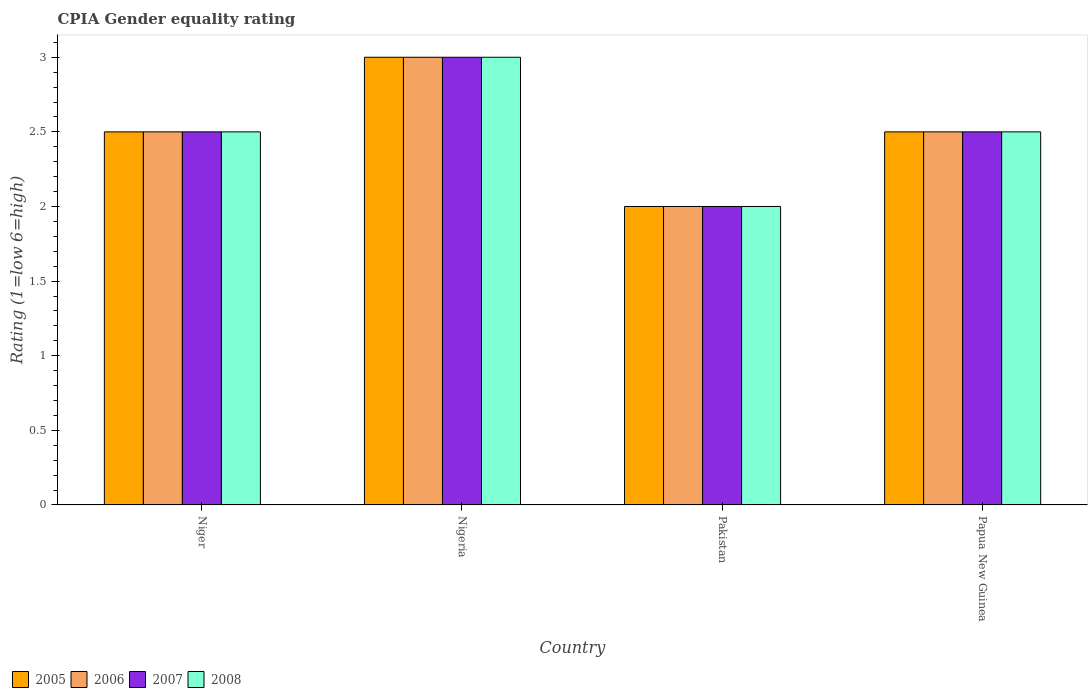How many different coloured bars are there?
Provide a succinct answer. 4. How many groups of bars are there?
Your answer should be compact. 4. Are the number of bars per tick equal to the number of legend labels?
Ensure brevity in your answer.  Yes. What is the label of the 4th group of bars from the left?
Provide a short and direct response. Papua New Guinea. In how many cases, is the number of bars for a given country not equal to the number of legend labels?
Your answer should be compact. 0. Across all countries, what is the minimum CPIA rating in 2008?
Give a very brief answer. 2. In which country was the CPIA rating in 2007 maximum?
Your answer should be very brief. Nigeria. In which country was the CPIA rating in 2005 minimum?
Ensure brevity in your answer.  Pakistan. What is the difference between the CPIA rating of/in 2008 and CPIA rating of/in 2005 in Nigeria?
Give a very brief answer. 0. In how many countries, is the CPIA rating in 2005 greater than 2.1?
Give a very brief answer. 3. What is the ratio of the CPIA rating in 2007 in Pakistan to that in Papua New Guinea?
Your answer should be very brief. 0.8. What is the difference between the highest and the second highest CPIA rating in 2008?
Provide a short and direct response. -0.5. Is the sum of the CPIA rating in 2008 in Niger and Pakistan greater than the maximum CPIA rating in 2006 across all countries?
Your response must be concise. Yes. Are all the bars in the graph horizontal?
Your response must be concise. No. How many countries are there in the graph?
Your response must be concise. 4. What is the difference between two consecutive major ticks on the Y-axis?
Your answer should be very brief. 0.5. Does the graph contain any zero values?
Your answer should be compact. No. Does the graph contain grids?
Provide a short and direct response. No. Where does the legend appear in the graph?
Provide a short and direct response. Bottom left. How many legend labels are there?
Offer a terse response. 4. What is the title of the graph?
Your answer should be very brief. CPIA Gender equality rating. Does "1961" appear as one of the legend labels in the graph?
Provide a succinct answer. No. What is the label or title of the Y-axis?
Your answer should be compact. Rating (1=low 6=high). What is the Rating (1=low 6=high) of 2006 in Niger?
Ensure brevity in your answer.  2.5. What is the Rating (1=low 6=high) in 2007 in Niger?
Provide a succinct answer. 2.5. What is the Rating (1=low 6=high) in 2007 in Nigeria?
Make the answer very short. 3. What is the Rating (1=low 6=high) in 2008 in Nigeria?
Provide a short and direct response. 3. What is the Rating (1=low 6=high) of 2006 in Pakistan?
Your answer should be very brief. 2. What is the Rating (1=low 6=high) in 2006 in Papua New Guinea?
Your answer should be very brief. 2.5. Across all countries, what is the maximum Rating (1=low 6=high) in 2005?
Your answer should be very brief. 3. Across all countries, what is the maximum Rating (1=low 6=high) in 2008?
Your answer should be compact. 3. Across all countries, what is the minimum Rating (1=low 6=high) of 2007?
Make the answer very short. 2. What is the total Rating (1=low 6=high) of 2006 in the graph?
Your answer should be very brief. 10. What is the total Rating (1=low 6=high) of 2007 in the graph?
Offer a very short reply. 10. What is the total Rating (1=low 6=high) of 2008 in the graph?
Your answer should be compact. 10. What is the difference between the Rating (1=low 6=high) of 2005 in Niger and that in Nigeria?
Offer a terse response. -0.5. What is the difference between the Rating (1=low 6=high) of 2006 in Niger and that in Nigeria?
Give a very brief answer. -0.5. What is the difference between the Rating (1=low 6=high) in 2007 in Niger and that in Nigeria?
Your response must be concise. -0.5. What is the difference between the Rating (1=low 6=high) of 2006 in Niger and that in Pakistan?
Keep it short and to the point. 0.5. What is the difference between the Rating (1=low 6=high) in 2008 in Niger and that in Pakistan?
Give a very brief answer. 0.5. What is the difference between the Rating (1=low 6=high) in 2005 in Niger and that in Papua New Guinea?
Your answer should be compact. 0. What is the difference between the Rating (1=low 6=high) of 2006 in Niger and that in Papua New Guinea?
Offer a terse response. 0. What is the difference between the Rating (1=low 6=high) of 2008 in Niger and that in Papua New Guinea?
Make the answer very short. 0. What is the difference between the Rating (1=low 6=high) of 2006 in Nigeria and that in Pakistan?
Provide a short and direct response. 1. What is the difference between the Rating (1=low 6=high) in 2008 in Nigeria and that in Pakistan?
Offer a terse response. 1. What is the difference between the Rating (1=low 6=high) in 2005 in Nigeria and that in Papua New Guinea?
Provide a succinct answer. 0.5. What is the difference between the Rating (1=low 6=high) of 2006 in Nigeria and that in Papua New Guinea?
Provide a short and direct response. 0.5. What is the difference between the Rating (1=low 6=high) in 2007 in Nigeria and that in Papua New Guinea?
Your answer should be compact. 0.5. What is the difference between the Rating (1=low 6=high) in 2008 in Nigeria and that in Papua New Guinea?
Your answer should be compact. 0.5. What is the difference between the Rating (1=low 6=high) in 2006 in Pakistan and that in Papua New Guinea?
Make the answer very short. -0.5. What is the difference between the Rating (1=low 6=high) of 2008 in Pakistan and that in Papua New Guinea?
Provide a succinct answer. -0.5. What is the difference between the Rating (1=low 6=high) in 2005 in Niger and the Rating (1=low 6=high) in 2006 in Nigeria?
Offer a terse response. -0.5. What is the difference between the Rating (1=low 6=high) of 2005 in Niger and the Rating (1=low 6=high) of 2007 in Pakistan?
Make the answer very short. 0.5. What is the difference between the Rating (1=low 6=high) in 2005 in Niger and the Rating (1=low 6=high) in 2008 in Pakistan?
Your response must be concise. 0.5. What is the difference between the Rating (1=low 6=high) of 2007 in Niger and the Rating (1=low 6=high) of 2008 in Pakistan?
Give a very brief answer. 0.5. What is the difference between the Rating (1=low 6=high) of 2005 in Niger and the Rating (1=low 6=high) of 2007 in Papua New Guinea?
Ensure brevity in your answer.  0. What is the difference between the Rating (1=low 6=high) of 2005 in Niger and the Rating (1=low 6=high) of 2008 in Papua New Guinea?
Your answer should be compact. 0. What is the difference between the Rating (1=low 6=high) in 2006 in Niger and the Rating (1=low 6=high) in 2007 in Papua New Guinea?
Keep it short and to the point. 0. What is the difference between the Rating (1=low 6=high) in 2006 in Niger and the Rating (1=low 6=high) in 2008 in Papua New Guinea?
Give a very brief answer. 0. What is the difference between the Rating (1=low 6=high) in 2005 in Nigeria and the Rating (1=low 6=high) in 2007 in Pakistan?
Offer a terse response. 1. What is the difference between the Rating (1=low 6=high) in 2006 in Nigeria and the Rating (1=low 6=high) in 2008 in Pakistan?
Ensure brevity in your answer.  1. What is the difference between the Rating (1=low 6=high) of 2005 in Nigeria and the Rating (1=low 6=high) of 2008 in Papua New Guinea?
Your answer should be compact. 0.5. What is the difference between the Rating (1=low 6=high) in 2007 in Nigeria and the Rating (1=low 6=high) in 2008 in Papua New Guinea?
Offer a terse response. 0.5. What is the difference between the Rating (1=low 6=high) of 2006 in Pakistan and the Rating (1=low 6=high) of 2007 in Papua New Guinea?
Your answer should be very brief. -0.5. What is the difference between the Rating (1=low 6=high) of 2005 and Rating (1=low 6=high) of 2006 in Niger?
Your response must be concise. 0. What is the difference between the Rating (1=low 6=high) in 2005 and Rating (1=low 6=high) in 2008 in Niger?
Your answer should be very brief. 0. What is the difference between the Rating (1=low 6=high) of 2006 and Rating (1=low 6=high) of 2008 in Niger?
Provide a short and direct response. 0. What is the difference between the Rating (1=low 6=high) of 2005 and Rating (1=low 6=high) of 2006 in Nigeria?
Your answer should be very brief. 0. What is the difference between the Rating (1=low 6=high) in 2005 and Rating (1=low 6=high) in 2007 in Nigeria?
Your answer should be compact. 0. What is the difference between the Rating (1=low 6=high) in 2007 and Rating (1=low 6=high) in 2008 in Nigeria?
Your answer should be compact. 0. What is the difference between the Rating (1=low 6=high) of 2005 and Rating (1=low 6=high) of 2007 in Pakistan?
Your response must be concise. 0. What is the difference between the Rating (1=low 6=high) of 2006 and Rating (1=low 6=high) of 2007 in Pakistan?
Your answer should be very brief. 0. What is the difference between the Rating (1=low 6=high) in 2007 and Rating (1=low 6=high) in 2008 in Pakistan?
Your answer should be compact. 0. What is the difference between the Rating (1=low 6=high) in 2005 and Rating (1=low 6=high) in 2007 in Papua New Guinea?
Your response must be concise. 0. What is the difference between the Rating (1=low 6=high) in 2006 and Rating (1=low 6=high) in 2007 in Papua New Guinea?
Keep it short and to the point. 0. What is the difference between the Rating (1=low 6=high) in 2007 and Rating (1=low 6=high) in 2008 in Papua New Guinea?
Keep it short and to the point. 0. What is the ratio of the Rating (1=low 6=high) in 2007 in Niger to that in Nigeria?
Ensure brevity in your answer.  0.83. What is the ratio of the Rating (1=low 6=high) of 2008 in Niger to that in Pakistan?
Provide a succinct answer. 1.25. What is the ratio of the Rating (1=low 6=high) of 2005 in Niger to that in Papua New Guinea?
Give a very brief answer. 1. What is the ratio of the Rating (1=low 6=high) of 2006 in Niger to that in Papua New Guinea?
Provide a succinct answer. 1. What is the ratio of the Rating (1=low 6=high) of 2007 in Niger to that in Papua New Guinea?
Offer a terse response. 1. What is the ratio of the Rating (1=low 6=high) in 2006 in Nigeria to that in Pakistan?
Keep it short and to the point. 1.5. What is the ratio of the Rating (1=low 6=high) in 2007 in Nigeria to that in Pakistan?
Your response must be concise. 1.5. What is the ratio of the Rating (1=low 6=high) in 2005 in Pakistan to that in Papua New Guinea?
Your answer should be compact. 0.8. What is the ratio of the Rating (1=low 6=high) of 2006 in Pakistan to that in Papua New Guinea?
Provide a succinct answer. 0.8. What is the ratio of the Rating (1=low 6=high) in 2008 in Pakistan to that in Papua New Guinea?
Ensure brevity in your answer.  0.8. What is the difference between the highest and the second highest Rating (1=low 6=high) in 2007?
Your answer should be compact. 0.5. What is the difference between the highest and the second highest Rating (1=low 6=high) in 2008?
Give a very brief answer. 0.5. What is the difference between the highest and the lowest Rating (1=low 6=high) in 2007?
Give a very brief answer. 1. 